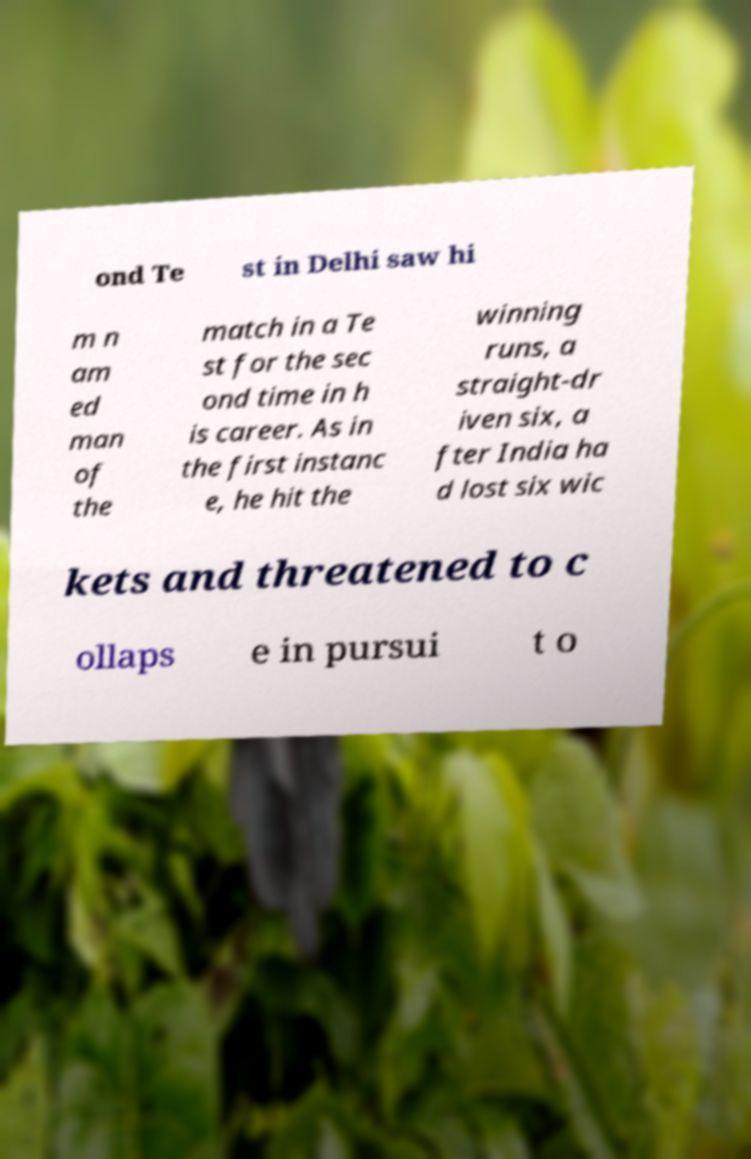Please identify and transcribe the text found in this image. ond Te st in Delhi saw hi m n am ed man of the match in a Te st for the sec ond time in h is career. As in the first instanc e, he hit the winning runs, a straight-dr iven six, a fter India ha d lost six wic kets and threatened to c ollaps e in pursui t o 